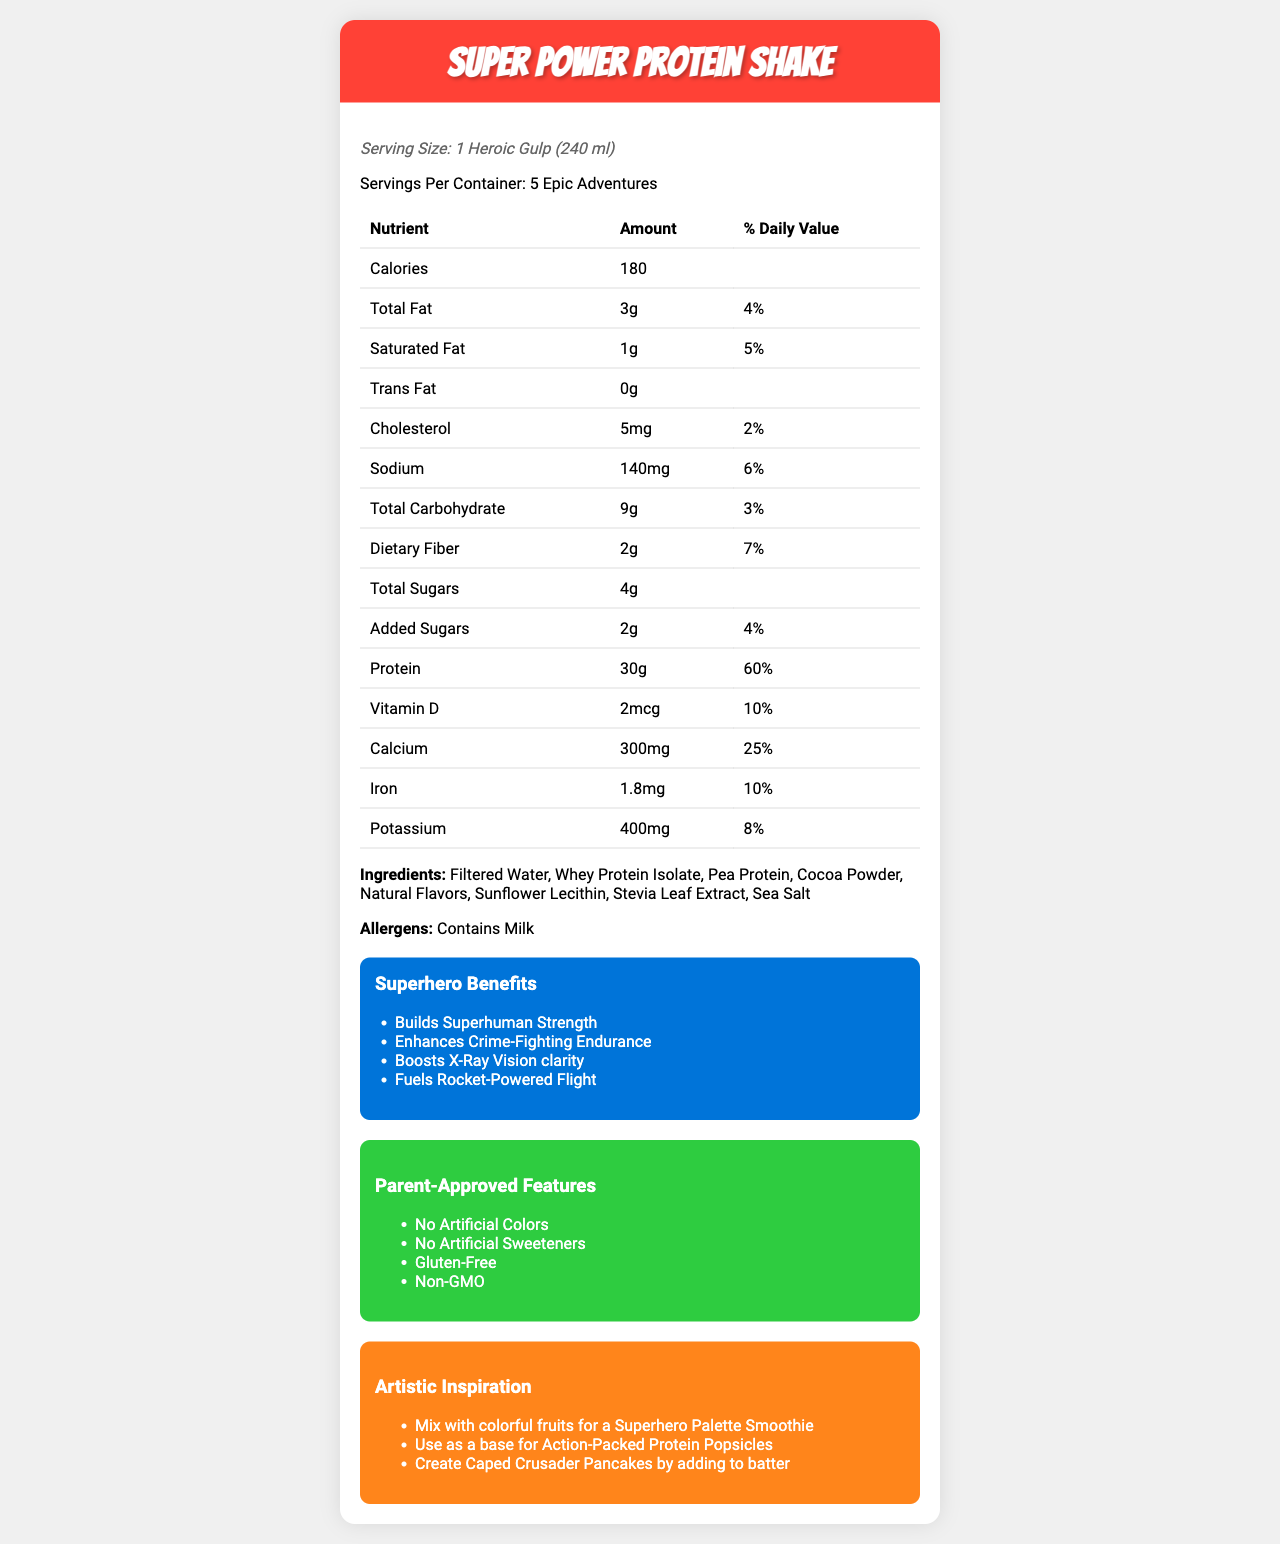what is the serving size? The document states the serving size as "1 Heroic Gulp (240 ml)".
Answer: 1 Heroic Gulp (240 ml) how many servings are there per container? The document specifies that there are "5 Epic Adventures" per container.
Answer: 5 Epic Adventures how many calories are in one serving? The document lists the calorie content as "180" for one serving.
Answer: 180 what is the amount of protein per serving? The protein content per serving is specified as "30g" in the document.
Answer: 30g how much calcium does one serving provide in terms of daily value percentage? The document indicates that one serving provides "25%" of the daily value for calcium.
Answer: 25% which of the following is not listed as a superhero benefit? A. Builds Superhuman Strength B. Enhances Crime-Fighting Endurance C. Improves Night Vision D. Fuels Rocket-Powered Flight The document lists "Builds Superhuman Strength", "Enhances Crime-Fighting Endurance", and "Fuels Rocket-Powered Flight" but does not mention "Improves Night Vision".
Answer: C. Improves Night Vision how much sugar is added in each serving? The document specifies "Added Sugars" as "2g" per serving.
Answer: 2g what is the daily value percentage for dietary fiber per serving? The document lists the daily value percentage for dietary fiber as "7%" per serving.
Answer: 7% which ingredient is first in the list? The document lists "Filtered Water" as the first ingredient.
Answer: Filtered Water which of the following parent-approved features is not mentioned in the document? A. No Artificial Colors B. No Artificial Sweeteners C. Gluten-Free D. Organic The document mentions "No Artificial Colors", "No Artificial Sweeteners", and "Gluten-Free" but does not list "Organic".
Answer: D. Organic does the product contain any allergens? The document states that the product "Contains Milk", which is an allergen.
Answer: Yes what are some creative serving sizes suggested in the document? The document lists four creative serving sizes: "1 Mighty Mouthful (60 ml)", "1 Sidekick Sip (120 ml)", "1 Heroic Gulp (240 ml)", and "1 Superhero Chug (480 ml)".
Answer: 1 Mighty Mouthful (60 ml), 1 Sidekick Sip (120 ml), 1 Heroic Gulp (240 ml), 1 Superhero Chug (480 ml) what is the total fat content per serving? The document specifies the total fat content per serving as "3g".
Answer: 3g summarize the main idea of the document. The document provides comprehensive details about the "Super Power Protein Shake," including its nutritional content, ingredients, benefits, and different serving suggestions while highlighting features approved by parents and creative ideas for consumption.
Answer: The document contains the nutrition facts for "Super Power Protein Shake," presenting detailed information about serving sizes, ingredients, allergens, and health benefits. It emphasizes parent-approved features and provides creative ways to enjoy the product. what is the recommended serving size for a quick snack? The document lists several serving sizes but does not specify which one is recommended for a quick snack.
Answer: Cannot be determined 